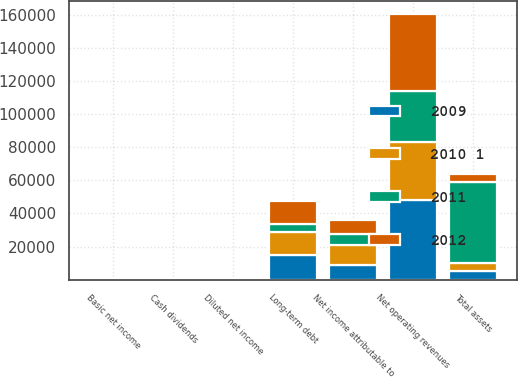Convert chart to OTSL. <chart><loc_0><loc_0><loc_500><loc_500><stacked_bar_chart><ecel><fcel>Net operating revenues<fcel>Net income attributable to<fcel>Basic net income<fcel>Diluted net income<fcel>Cash dividends<fcel>Total assets<fcel>Long-term debt<nl><fcel>2009<fcel>48017<fcel>9019<fcel>2<fcel>1.97<fcel>1.02<fcel>5059<fcel>14736<nl><fcel>2012<fcel>46542<fcel>8584<fcel>1.88<fcel>1.85<fcel>0.94<fcel>5059<fcel>13656<nl><fcel>2010 1<fcel>35119<fcel>11787<fcel>2.55<fcel>2.53<fcel>0.88<fcel>5059<fcel>14041<nl><fcel>2011<fcel>30990<fcel>6797<fcel>1.47<fcel>1.46<fcel>0.82<fcel>48671<fcel>5059<nl></chart> 